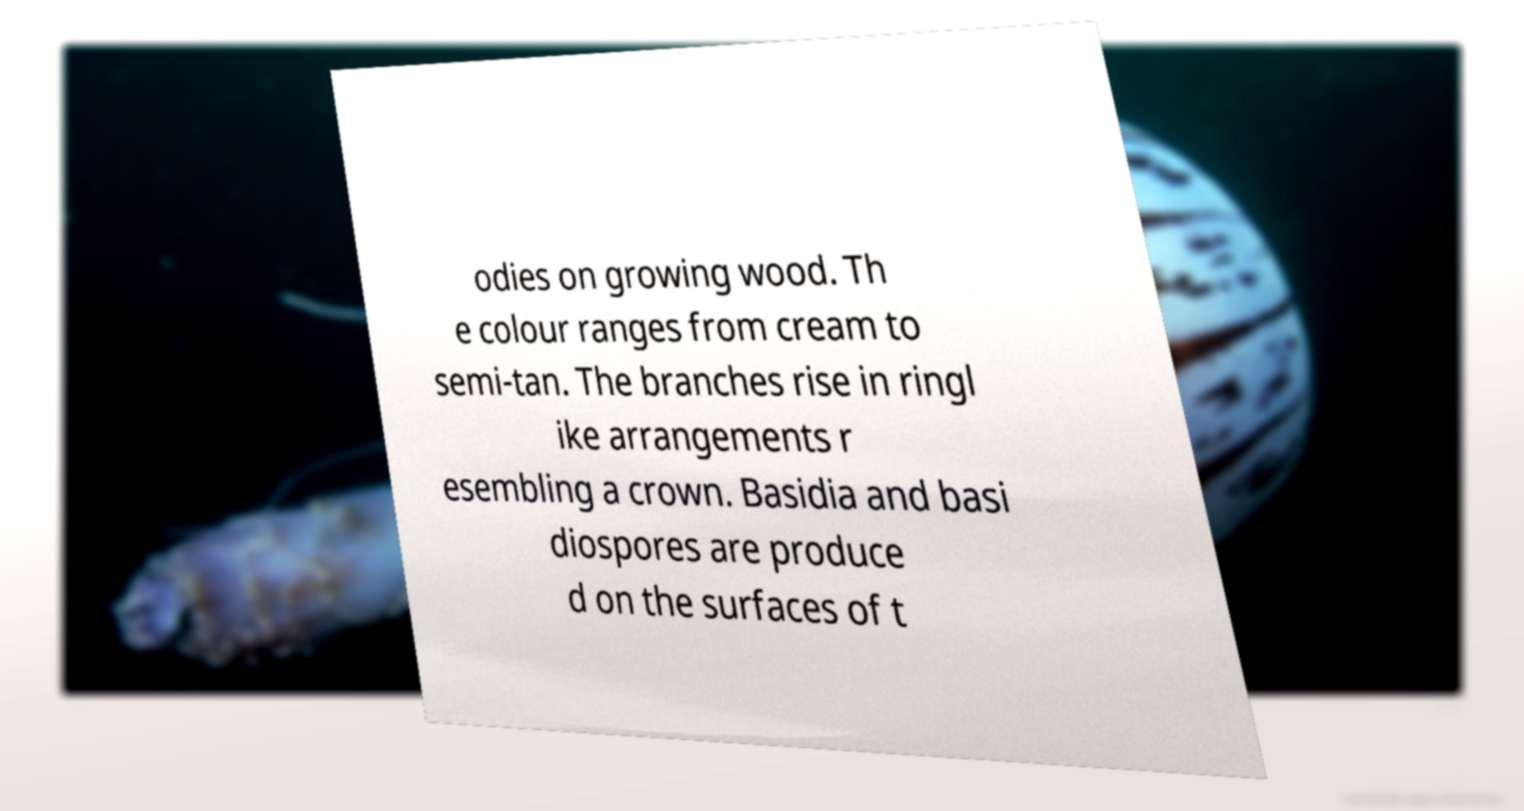Could you assist in decoding the text presented in this image and type it out clearly? odies on growing wood. Th e colour ranges from cream to semi-tan. The branches rise in ringl ike arrangements r esembling a crown. Basidia and basi diospores are produce d on the surfaces of t 